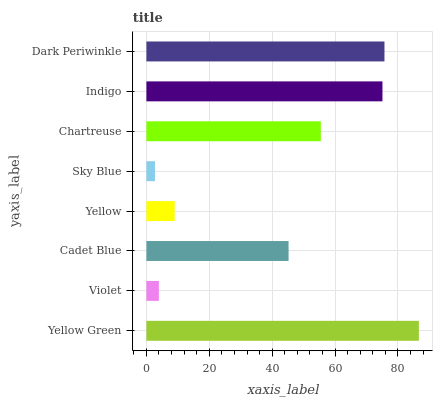Is Sky Blue the minimum?
Answer yes or no. Yes. Is Yellow Green the maximum?
Answer yes or no. Yes. Is Violet the minimum?
Answer yes or no. No. Is Violet the maximum?
Answer yes or no. No. Is Yellow Green greater than Violet?
Answer yes or no. Yes. Is Violet less than Yellow Green?
Answer yes or no. Yes. Is Violet greater than Yellow Green?
Answer yes or no. No. Is Yellow Green less than Violet?
Answer yes or no. No. Is Chartreuse the high median?
Answer yes or no. Yes. Is Cadet Blue the low median?
Answer yes or no. Yes. Is Sky Blue the high median?
Answer yes or no. No. Is Yellow the low median?
Answer yes or no. No. 